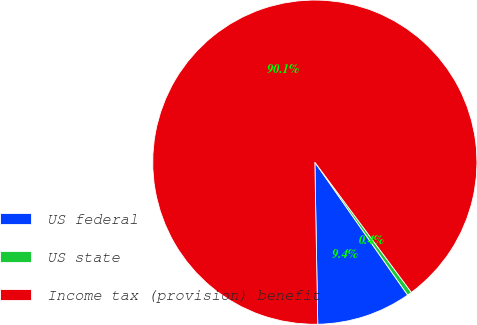Convert chart. <chart><loc_0><loc_0><loc_500><loc_500><pie_chart><fcel>US federal<fcel>US state<fcel>Income tax (provision) benefit<nl><fcel>9.42%<fcel>0.45%<fcel>90.14%<nl></chart> 